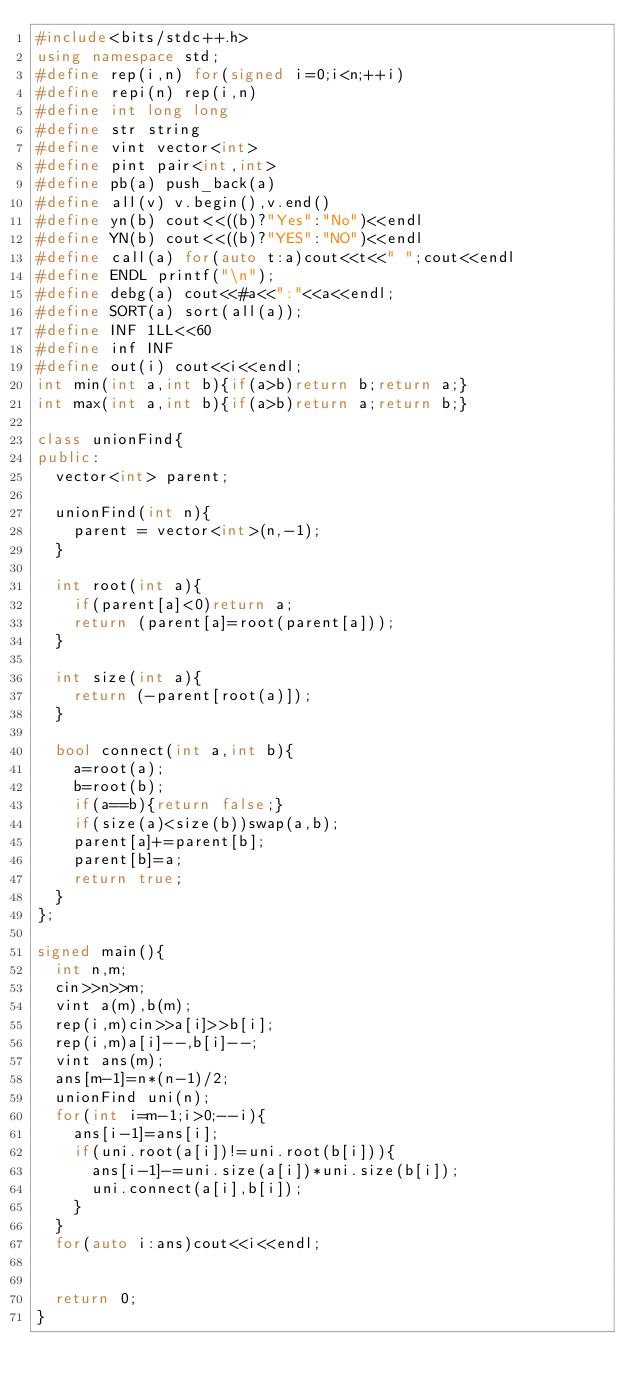<code> <loc_0><loc_0><loc_500><loc_500><_C++_>#include<bits/stdc++.h>
using namespace std;
#define rep(i,n) for(signed i=0;i<n;++i)
#define repi(n) rep(i,n)
#define int long long
#define str string
#define vint vector<int>
#define pint pair<int,int>
#define pb(a) push_back(a)
#define all(v) v.begin(),v.end()
#define yn(b) cout<<((b)?"Yes":"No")<<endl
#define YN(b) cout<<((b)?"YES":"NO")<<endl
#define call(a) for(auto t:a)cout<<t<<" ";cout<<endl
#define ENDL printf("\n");
#define debg(a) cout<<#a<<":"<<a<<endl;
#define SORT(a) sort(all(a));
#define INF 1LL<<60
#define inf INF
#define out(i) cout<<i<<endl;
int min(int a,int b){if(a>b)return b;return a;}
int max(int a,int b){if(a>b)return a;return b;}

class unionFind{
public:  
  vector<int> parent;
  
  unionFind(int n){
    parent = vector<int>(n,-1);
  }

  int root(int a){
    if(parent[a]<0)return a;
    return (parent[a]=root(parent[a]));
  }

  int size(int a){
    return (-parent[root(a)]);
  }

  bool connect(int a,int b){
    a=root(a);
    b=root(b);
    if(a==b){return false;}
    if(size(a)<size(b))swap(a,b);
    parent[a]+=parent[b];
    parent[b]=a;
    return true;
  }
};

signed main(){
  int n,m;
  cin>>n>>m;
  vint a(m),b(m);
  rep(i,m)cin>>a[i]>>b[i];
  rep(i,m)a[i]--,b[i]--;
  vint ans(m);
  ans[m-1]=n*(n-1)/2;
  unionFind uni(n);
  for(int i=m-1;i>0;--i){
    ans[i-1]=ans[i];
    if(uni.root(a[i])!=uni.root(b[i])){
      ans[i-1]-=uni.size(a[i])*uni.size(b[i]);
      uni.connect(a[i],b[i]);
    }
  }
  for(auto i:ans)cout<<i<<endl;
  

  return 0;
}

</code> 